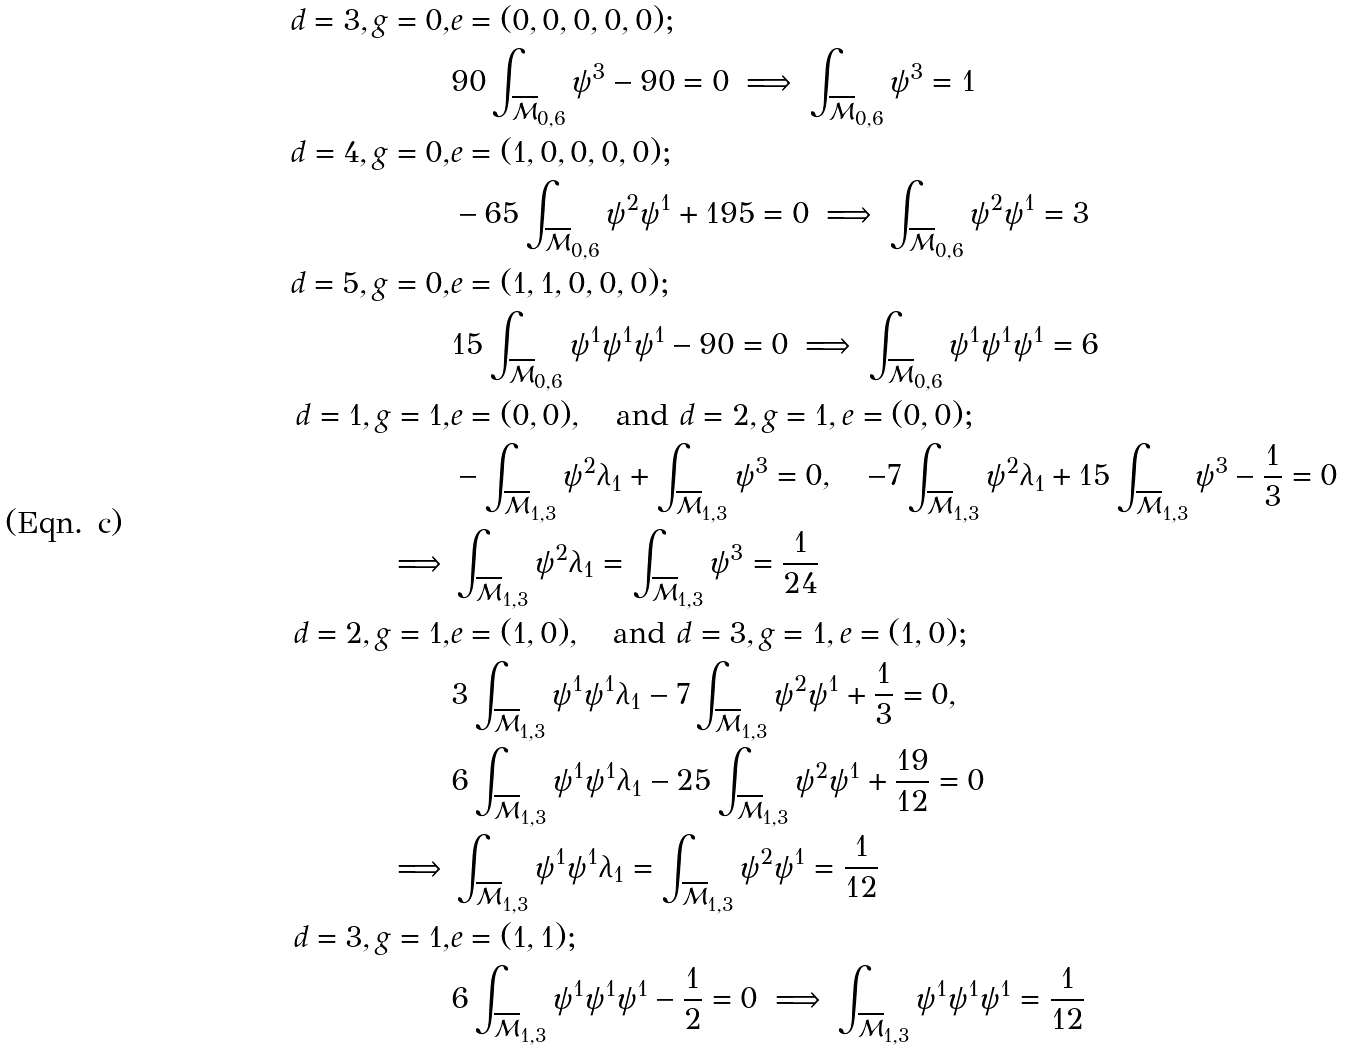<formula> <loc_0><loc_0><loc_500><loc_500>d = 3 , g = 0 , & e = ( 0 , 0 , 0 , 0 , 0 ) ; \\ & 9 0 \int _ { \overline { \mathcal { M } } _ { 0 , 6 } } \psi ^ { 3 } - 9 0 = 0 \implies \int _ { \overline { \mathcal { M } } _ { 0 , 6 } } \psi ^ { 3 } = 1 \\ d = 4 , g = 0 , & e = ( 1 , 0 , 0 , 0 , 0 ) ; \\ & - 6 5 \int _ { \overline { \mathcal { M } } _ { 0 , 6 } } \psi ^ { 2 } \psi ^ { 1 } + 1 9 5 = 0 \implies \int _ { \overline { \mathcal { M } } _ { 0 , 6 } } \psi ^ { 2 } \psi ^ { 1 } = 3 \\ d = 5 , g = 0 , & e = ( 1 , 1 , 0 , 0 , 0 ) ; \\ & 1 5 \int _ { \overline { \mathcal { M } } _ { 0 , 6 } } \psi ^ { 1 } \psi ^ { 1 } \psi ^ { 1 } - 9 0 = 0 \implies \int _ { \overline { \mathcal { M } } _ { 0 , 6 } } \psi ^ { 1 } \psi ^ { 1 } \psi ^ { 1 } = 6 \\ d = 1 , g = 1 , & e = ( 0 , 0 ) , \quad \text {and } d = 2 , g = 1 , e = ( 0 , 0 ) ; \\ & - \int _ { \overline { \mathcal { M } } _ { 1 , 3 } } \psi ^ { 2 } \lambda _ { 1 } + \int _ { \overline { \mathcal { M } } _ { 1 , 3 } } \psi ^ { 3 } = 0 , \quad - 7 \int _ { \overline { \mathcal { M } } _ { 1 , 3 } } \psi ^ { 2 } \lambda _ { 1 } + 1 5 \int _ { \overline { \mathcal { M } } _ { 1 , 3 } } \psi ^ { 3 } - \frac { 1 } { 3 } = 0 \\ \implies & \int _ { \overline { \mathcal { M } } _ { 1 , 3 } } \psi ^ { 2 } \lambda _ { 1 } = \int _ { \overline { \mathcal { M } } _ { 1 , 3 } } \psi ^ { 3 } = \frac { 1 } { 2 4 } \\ d = 2 , g = 1 , & e = ( 1 , 0 ) , \quad \text {and } d = 3 , g = 1 , e = ( 1 , 0 ) ; \\ & 3 \int _ { \overline { \mathcal { M } } _ { 1 , 3 } } \psi ^ { 1 } \psi ^ { 1 } \lambda _ { 1 } - 7 \int _ { \overline { \mathcal { M } } _ { 1 , 3 } } \psi ^ { 2 } \psi ^ { 1 } + \frac { 1 } { 3 } = 0 , \\ & 6 \int _ { \overline { \mathcal { M } } _ { 1 , 3 } } \psi ^ { 1 } \psi ^ { 1 } \lambda _ { 1 } - 2 5 \int _ { \overline { \mathcal { M } } _ { 1 , 3 } } \psi ^ { 2 } \psi ^ { 1 } + \frac { 1 9 } { 1 2 } = 0 \\ \implies & \int _ { \overline { \mathcal { M } } _ { 1 , 3 } } \psi ^ { 1 } \psi ^ { 1 } \lambda _ { 1 } = \int _ { \overline { \mathcal { M } } _ { 1 , 3 } } \psi ^ { 2 } \psi ^ { 1 } = \frac { 1 } { 1 2 } \\ d = 3 , g = 1 , & e = ( 1 , 1 ) ; \\ & 6 \int _ { \overline { \mathcal { M } } _ { 1 , 3 } } \psi ^ { 1 } \psi ^ { 1 } \psi ^ { 1 } - \frac { 1 } { 2 } = 0 \implies \int _ { \overline { \mathcal { M } } _ { 1 , 3 } } \psi ^ { 1 } \psi ^ { 1 } \psi ^ { 1 } = \frac { 1 } { 1 2 }</formula> 